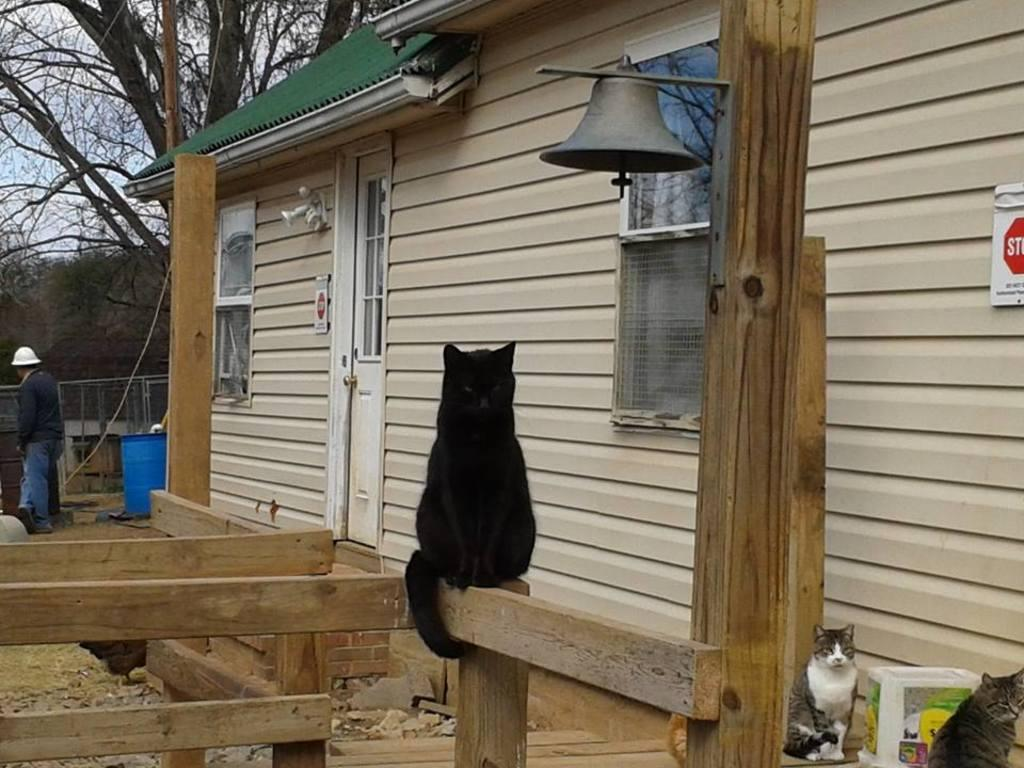What type of building is in the picture? There is a house in the picture. What animals can be seen in the picture? There are cats in the picture. Who is present in the picture? There is a man standing in the picture. What is the man wearing on his head? The man is wearing a cap. What type of vegetation is in the picture? There are trees in the picture. What object can be seen hanging in the picture? There is a bell in the picture. What can be read in the picture? There is a board with text in the picture. Where is the hospital located in the picture? There is no hospital present in the picture. What type of match is being played in the picture? There is no match being played in the picture. 